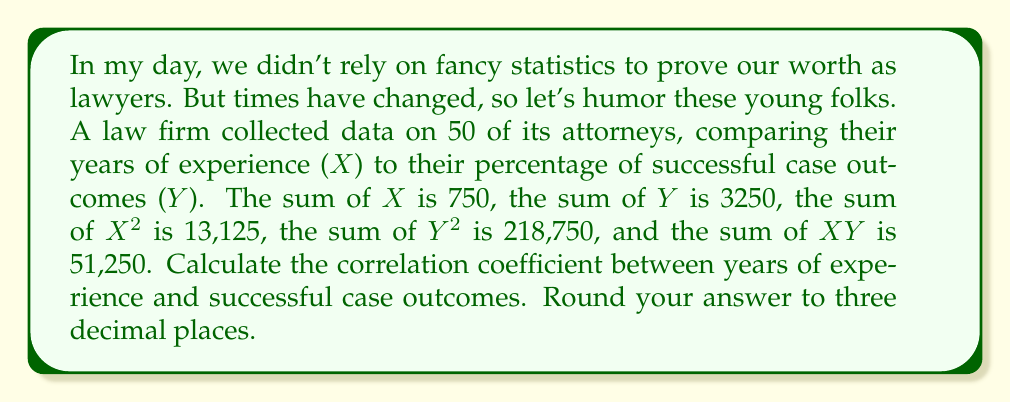Could you help me with this problem? To calculate the correlation coefficient, we'll use the formula:

$$ r = \frac{n\sum xy - \sum x \sum y}{\sqrt{[n\sum x^2 - (\sum x)^2][n\sum y^2 - (\sum y)^2]}} $$

Where:
n = 50 (number of attorneys)
$\sum x = 750$ (sum of years of experience)
$\sum y = 3250$ (sum of successful case percentages)
$\sum x^2 = 13,125$
$\sum y^2 = 218,750$
$\sum xy = 51,250$

Step 1: Calculate the numerator
$50(51,250) - (750)(3250) = 2,562,500 - 2,437,500 = 125,000$

Step 2: Calculate the first part of the denominator
$50(13,125) - (750)^2 = 656,250 - 562,500 = 93,750$

Step 3: Calculate the second part of the denominator
$50(218,750) - (3250)^2 = 10,937,500 - 10,562,500 = 375,000$

Step 4: Multiply the results from steps 2 and 3
$93,750 * 375,000 = 35,156,250,000$

Step 5: Take the square root of step 4
$\sqrt{35,156,250,000} = 187,500$

Step 6: Divide the numerator by the denominator
$r = \frac{125,000}{187,500} = 0.6666666...$

Step 7: Round to three decimal places
$r = 0.667$
Answer: 0.667 